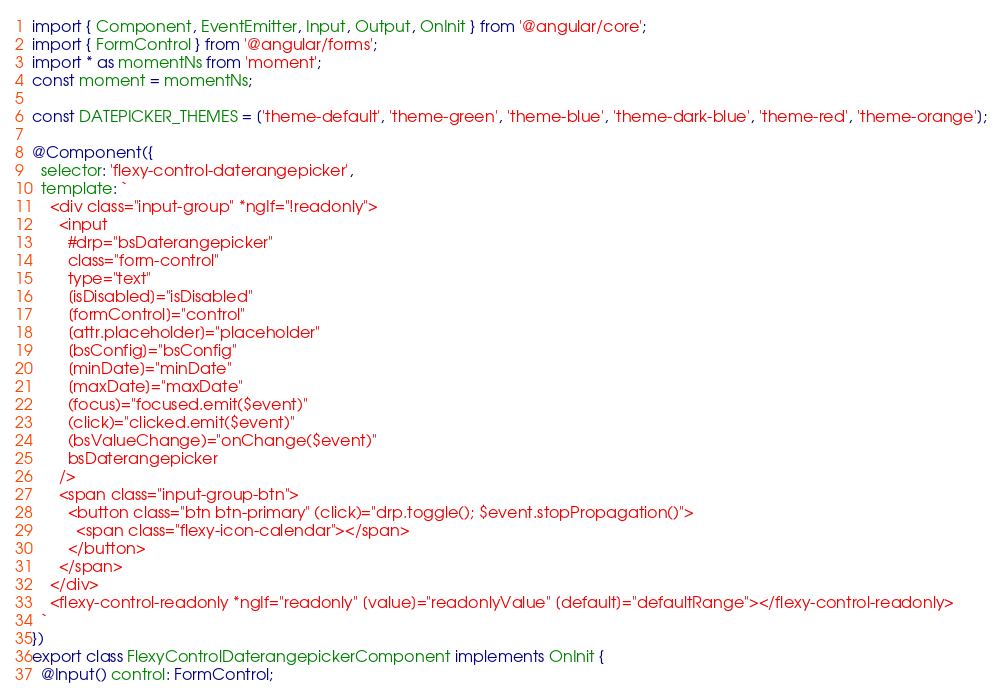<code> <loc_0><loc_0><loc_500><loc_500><_TypeScript_>import { Component, EventEmitter, Input, Output, OnInit } from '@angular/core';
import { FormControl } from '@angular/forms';
import * as momentNs from 'moment';
const moment = momentNs;

const DATEPICKER_THEMES = ['theme-default', 'theme-green', 'theme-blue', 'theme-dark-blue', 'theme-red', 'theme-orange'];

@Component({
  selector: 'flexy-control-daterangepicker',
  template: `
    <div class="input-group" *ngIf="!readonly">
      <input
        #drp="bsDaterangepicker"
        class="form-control"
        type="text"
        [isDisabled]="isDisabled"
        [formControl]="control"
        [attr.placeholder]="placeholder"
        [bsConfig]="bsConfig"
        [minDate]="minDate"
        [maxDate]="maxDate"
        (focus)="focused.emit($event)"
        (click)="clicked.emit($event)"
        (bsValueChange)="onChange($event)"
        bsDaterangepicker
      />
      <span class="input-group-btn">
        <button class="btn btn-primary" (click)="drp.toggle(); $event.stopPropagation()">
          <span class="flexy-icon-calendar"></span>
        </button>
      </span>
    </div>
    <flexy-control-readonly *ngIf="readonly" [value]="readonlyValue" [default]="defaultRange"></flexy-control-readonly>
  `
})
export class FlexyControlDaterangepickerComponent implements OnInit {
  @Input() control: FormControl;
</code> 